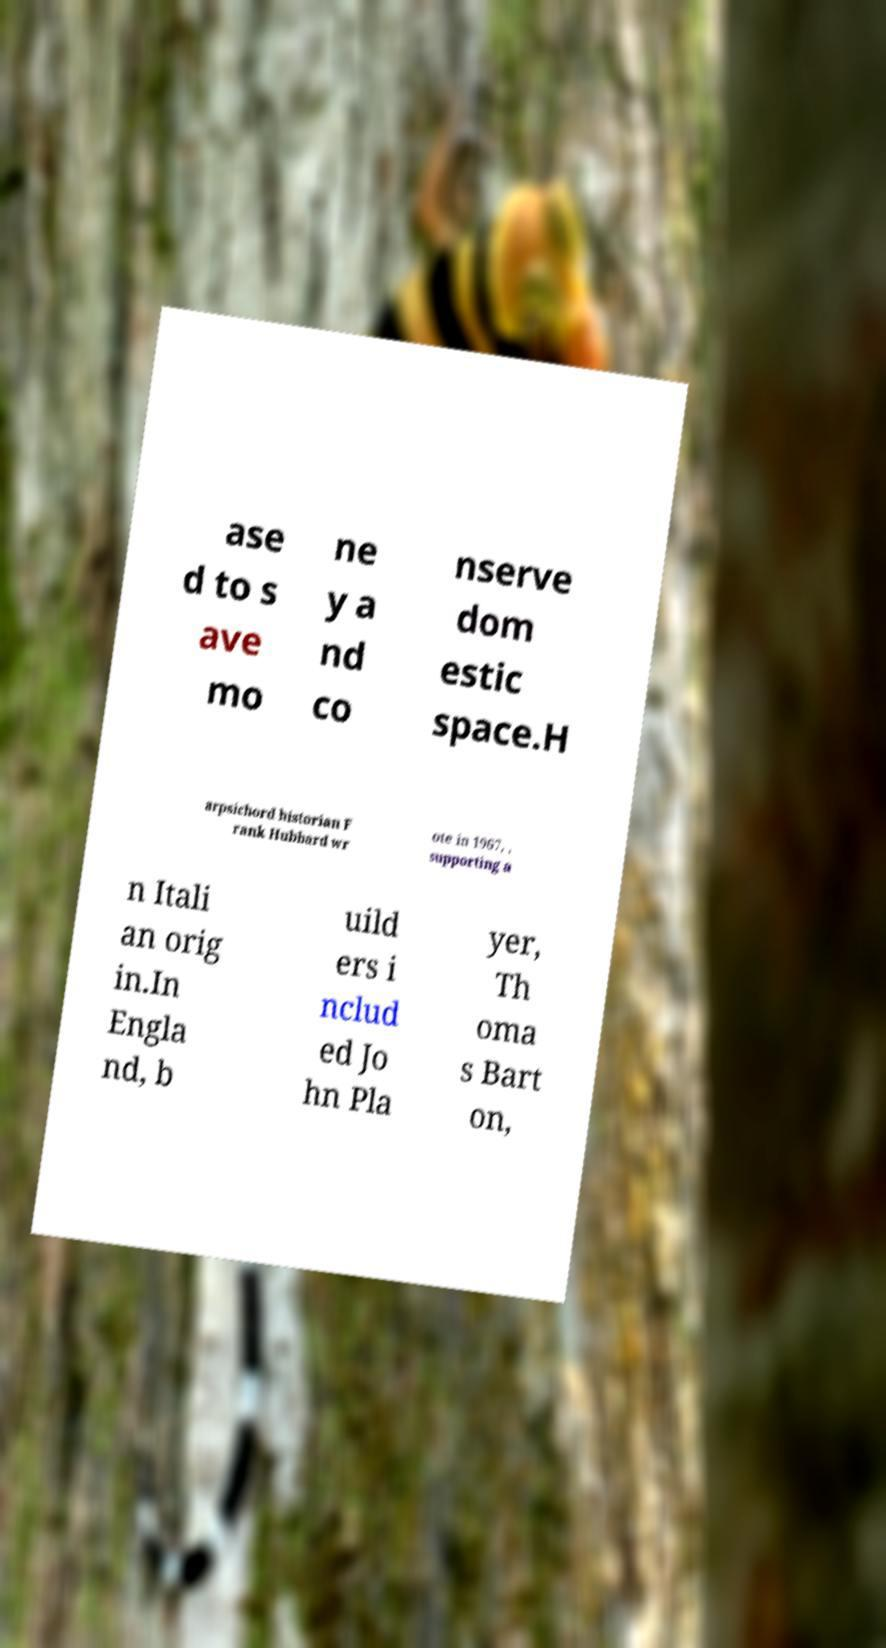Please read and relay the text visible in this image. What does it say? ase d to s ave mo ne y a nd co nserve dom estic space.H arpsichord historian F rank Hubbard wr ote in 1967, , supporting a n Itali an orig in.In Engla nd, b uild ers i nclud ed Jo hn Pla yer, Th oma s Bart on, 